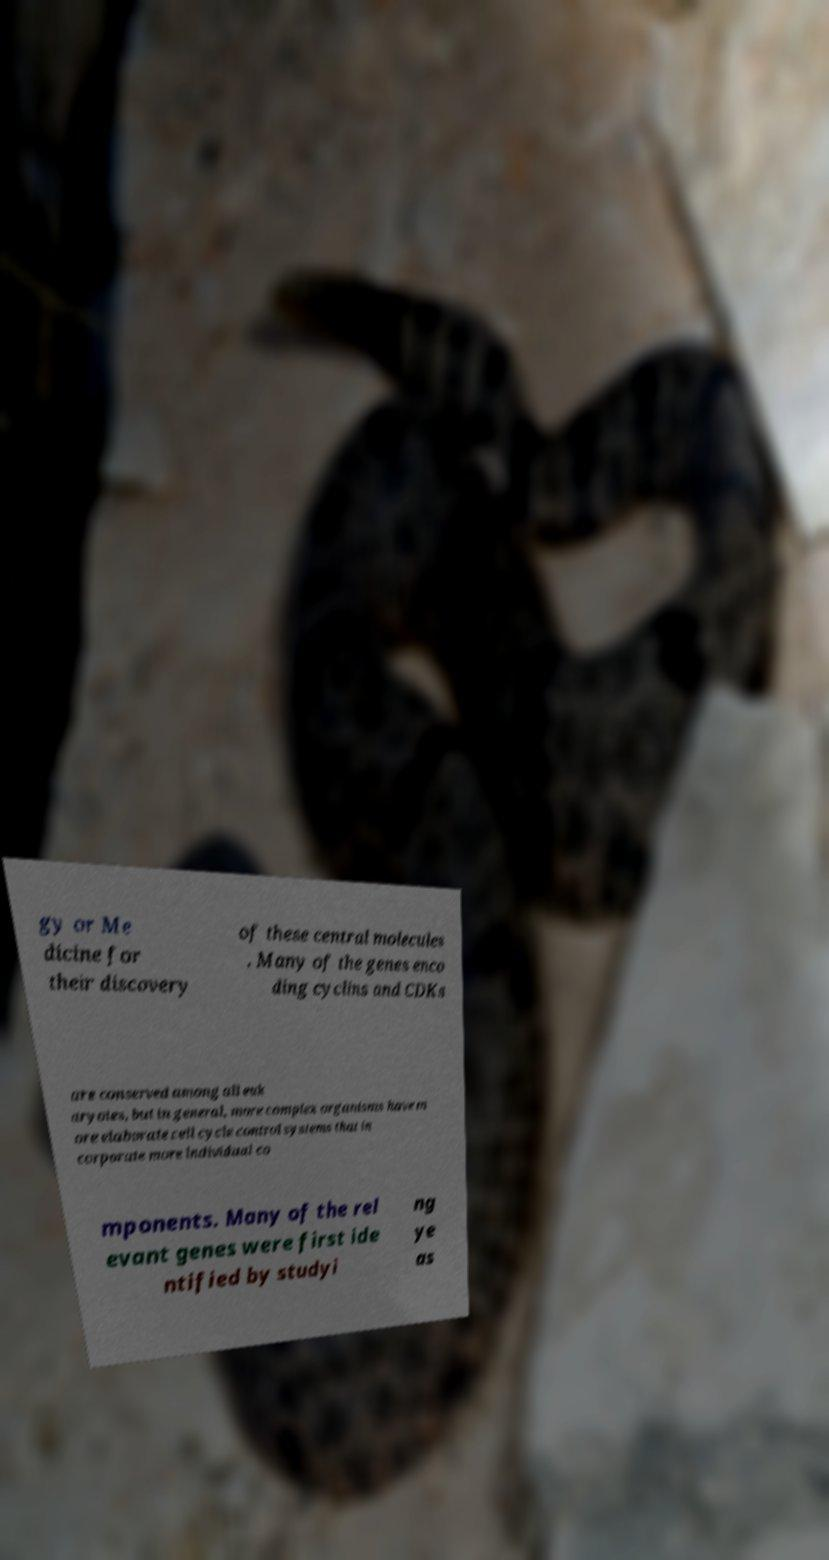I need the written content from this picture converted into text. Can you do that? gy or Me dicine for their discovery of these central molecules . Many of the genes enco ding cyclins and CDKs are conserved among all euk aryotes, but in general, more complex organisms have m ore elaborate cell cycle control systems that in corporate more individual co mponents. Many of the rel evant genes were first ide ntified by studyi ng ye as 